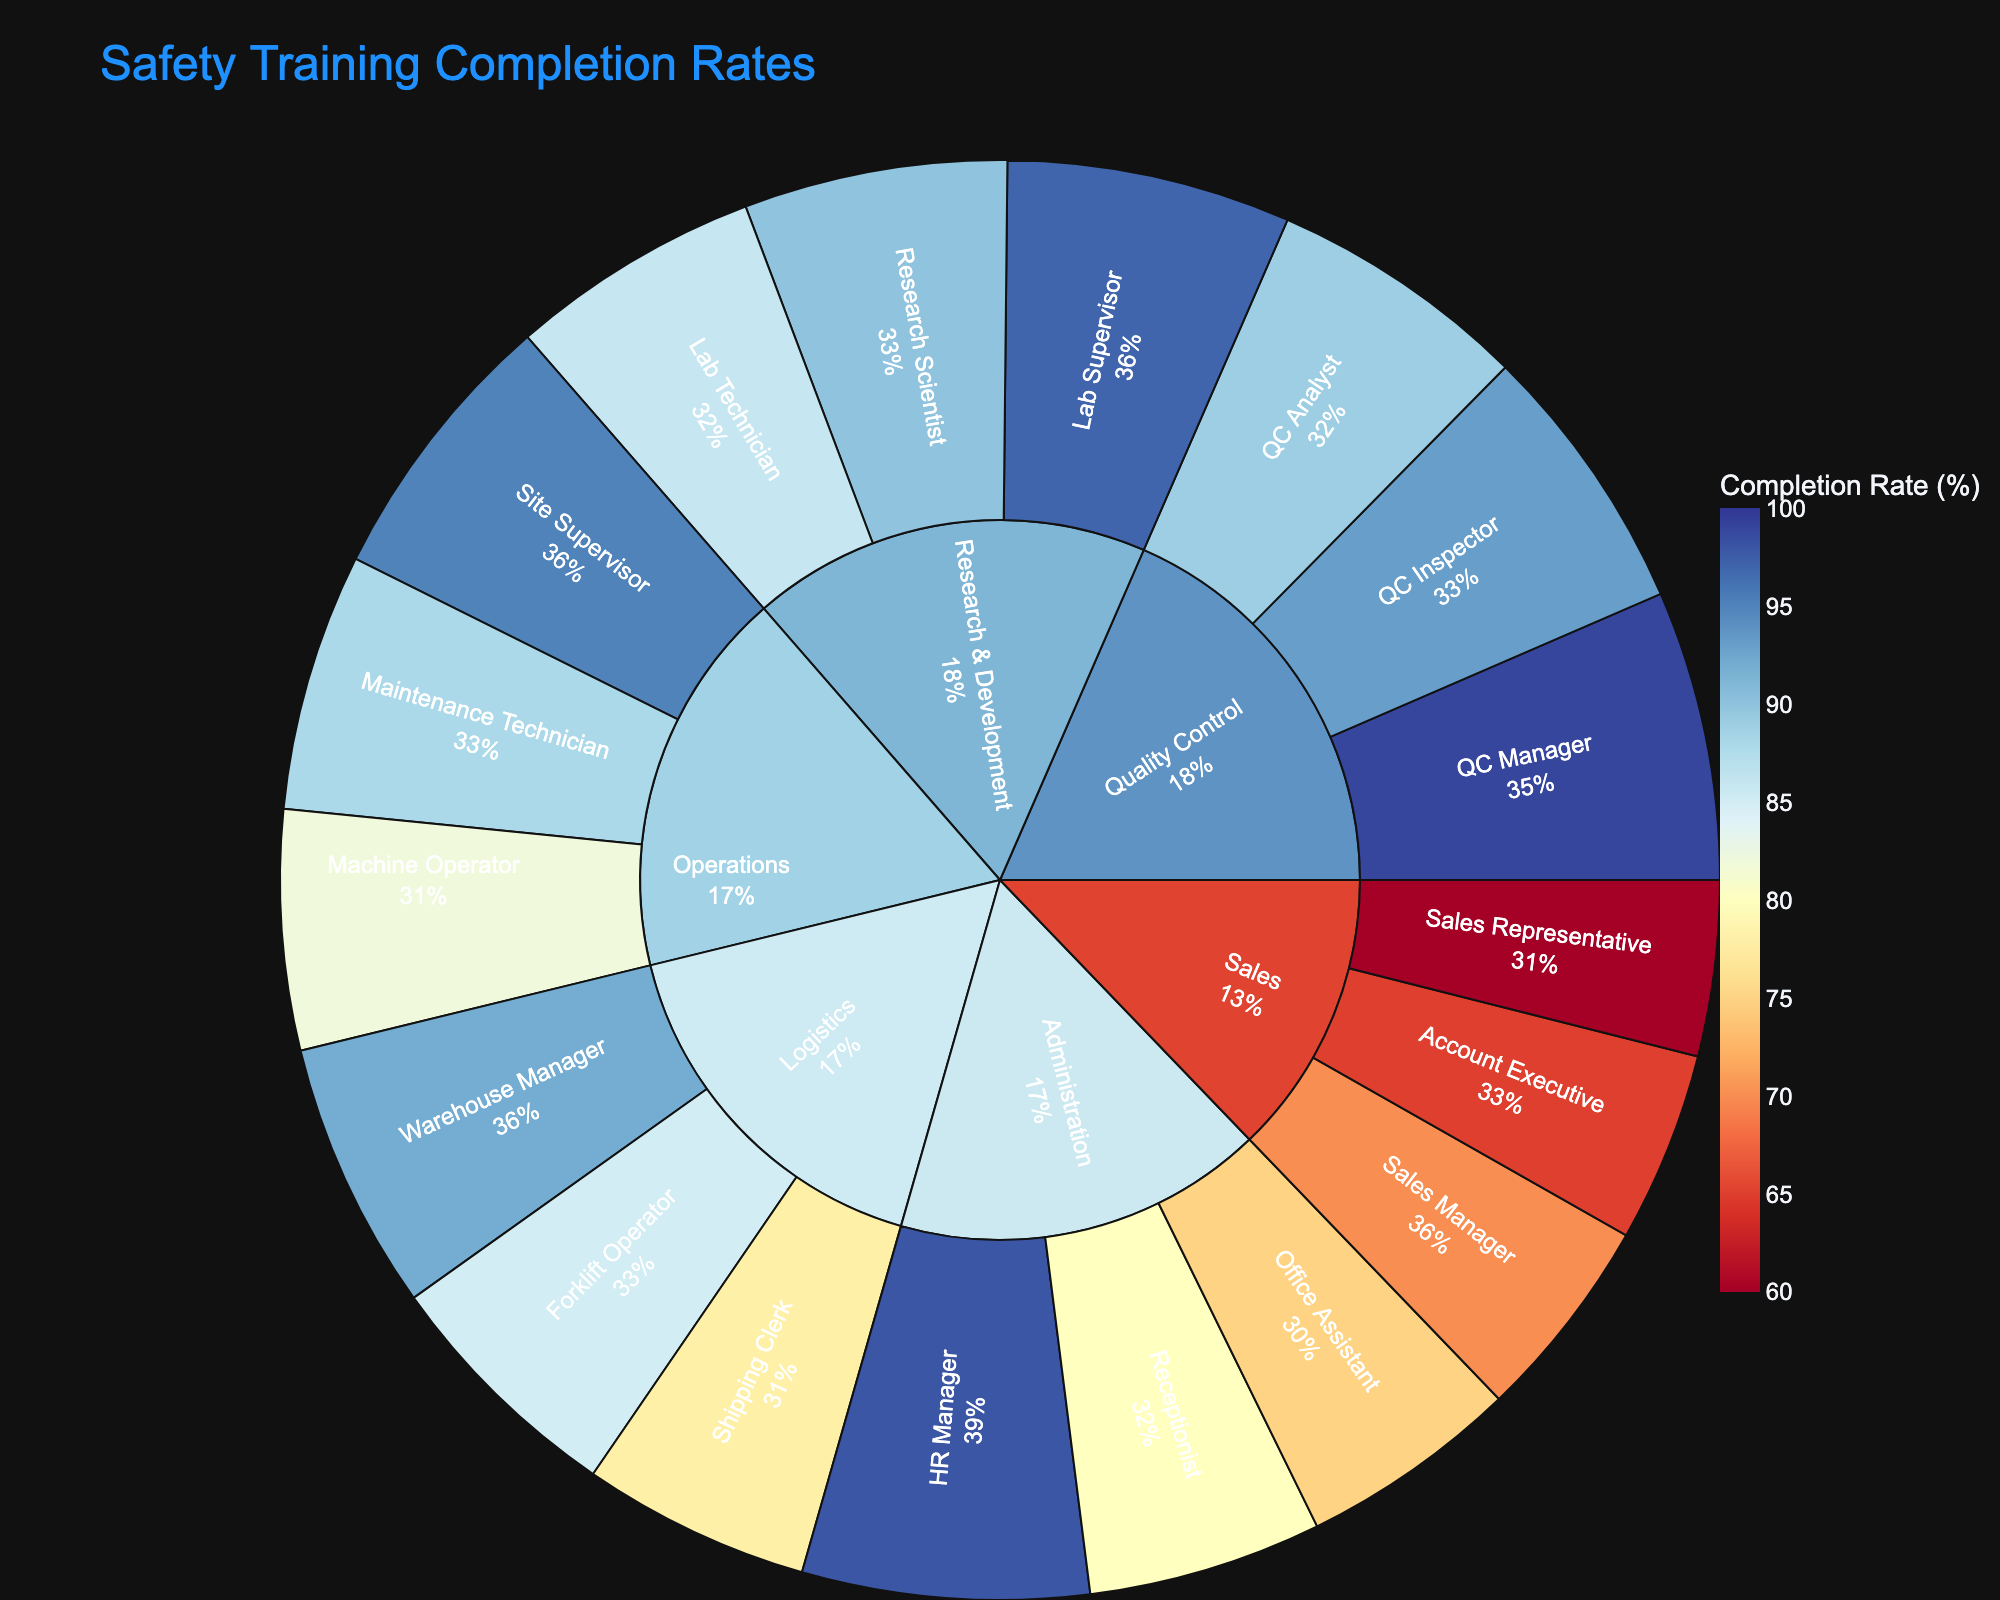What is the title of the sunburst plot? The title of the sunburst plot is located at the top of the figure and it provides a summary indication of the chart's content.
Answer: Safety Training Completion Rates What is the completion rate for the Operations department's Site Supervisor role? Locate the Operations department in the sunburst and then find the Site Supervisor segment within this department. The completion rate is indicated in the hover information.
Answer: 95% Which job role in the Administration department has the lowest completion rate? Find the Administration department in the sunburst and compare the completion rates for all job roles within this department.
Answer: Office Assistant Compare the completion rate of the Sales Manager to the QC Manager. Which one is higher? Locate the Sales and Quality Control departments in the sunburst. Identify the segments for Sales Manager and QC Manager and compare their completion rates.
Answer: QC Manager Which department has the highest average completion rate? Calculate the average completion rate for each department by summing the completion rates of all job roles within each department and then dividing by the number of job roles in that department. The department with the highest result is the answer.
Answer: Quality Control What percentage of the total completion rate for the Logistics department is contributed by the Forklift Operator role? Find the completion rates for all the job roles within Logistics and sum them up to get the total. Divide the Forklift Operator's completion rate by this total and multiply by 100.
Answer: 29.31% Identify the job role with the lowest completion rate overall. Examine the completion rates for all job roles across all departments in the sunburst chart to find the lowest value.
Answer: Sales Representative What's the difference in completion rates between the highest and lowest values in the figure? Identify the highest and lowest completion rates from the sunburst chart and subtract the lowest value from the highest one.
Answer: 39% Which two roles in the Research & Development department have the most similar completion rates? Look at the completion rates for all job roles in the Research & Development department and find the two closest in value.
Answer: Research Scientist and Lab Technician 